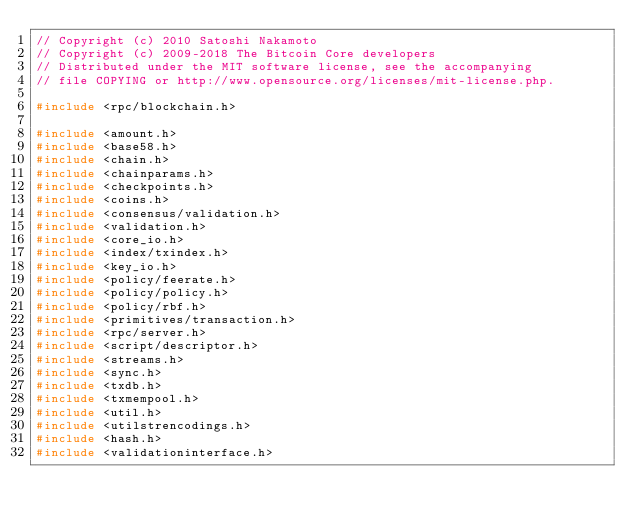Convert code to text. <code><loc_0><loc_0><loc_500><loc_500><_C++_>// Copyright (c) 2010 Satoshi Nakamoto
// Copyright (c) 2009-2018 The Bitcoin Core developers
// Distributed under the MIT software license, see the accompanying
// file COPYING or http://www.opensource.org/licenses/mit-license.php.

#include <rpc/blockchain.h>

#include <amount.h>
#include <base58.h>
#include <chain.h>
#include <chainparams.h>
#include <checkpoints.h>
#include <coins.h>
#include <consensus/validation.h>
#include <validation.h>
#include <core_io.h>
#include <index/txindex.h>
#include <key_io.h>
#include <policy/feerate.h>
#include <policy/policy.h>
#include <policy/rbf.h>
#include <primitives/transaction.h>
#include <rpc/server.h>
#include <script/descriptor.h>
#include <streams.h>
#include <sync.h>
#include <txdb.h>
#include <txmempool.h>
#include <util.h>
#include <utilstrencodings.h>
#include <hash.h>
#include <validationinterface.h></code> 